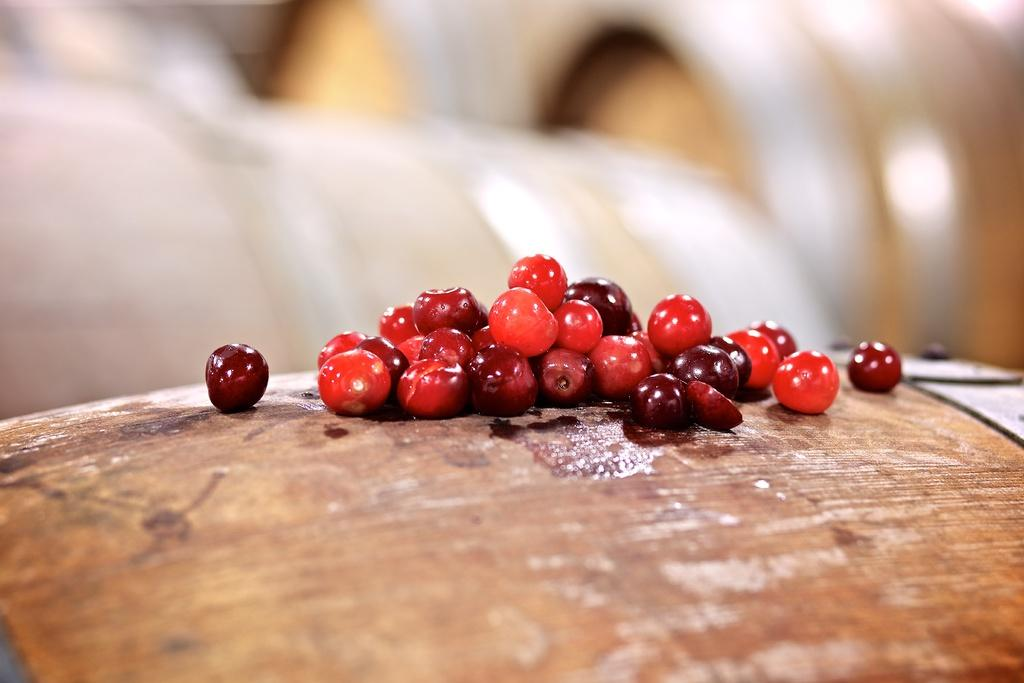What type of sleet is being used to answer the question in the image? There is no question or sleet present in the image, as no specific facts were provided. What type of sleet is being used to answer the question in the image? There is no question or sleet present in the image, as no specific facts were provided. 